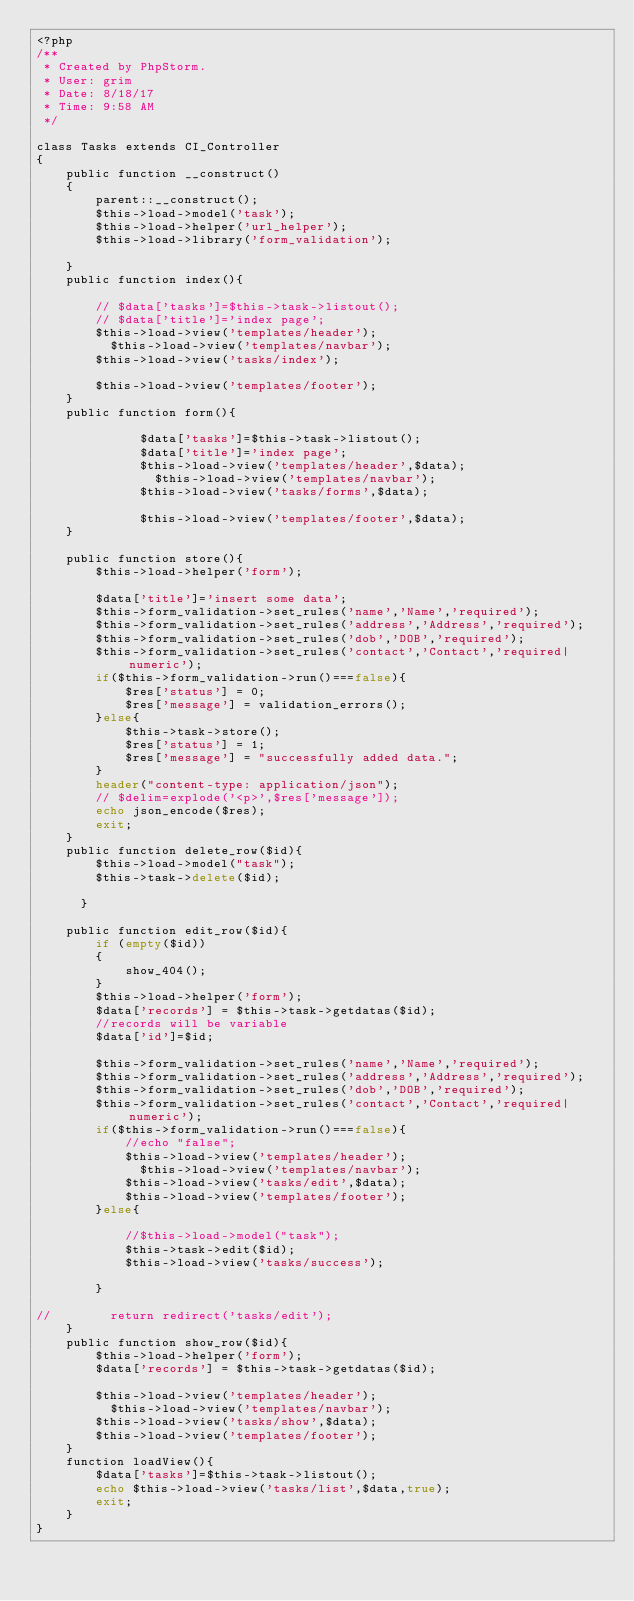<code> <loc_0><loc_0><loc_500><loc_500><_PHP_><?php
/**
 * Created by PhpStorm.
 * User: grim
 * Date: 8/18/17
 * Time: 9:58 AM
 */

class Tasks extends CI_Controller
{
    public function __construct()
    {
        parent::__construct();
        $this->load->model('task');
        $this->load->helper('url_helper');
        $this->load->library('form_validation');

    }
    public function index(){

        // $data['tasks']=$this->task->listout();
        // $data['title']='index page';
        $this->load->view('templates/header');
          $this->load->view('templates/navbar');
        $this->load->view('tasks/index');

        $this->load->view('templates/footer');
    }
    public function form(){

              $data['tasks']=$this->task->listout();
              $data['title']='index page';
              $this->load->view('templates/header',$data);
                $this->load->view('templates/navbar');
              $this->load->view('tasks/forms',$data);

              $this->load->view('templates/footer',$data);
    }

    public function store(){
        $this->load->helper('form');

        $data['title']='insert some data';
        $this->form_validation->set_rules('name','Name','required');
        $this->form_validation->set_rules('address','Address','required');
        $this->form_validation->set_rules('dob','DOB','required');
        $this->form_validation->set_rules('contact','Contact','required|numeric');
        if($this->form_validation->run()===false){
            $res['status'] = 0;
            $res['message'] = validation_errors();
        }else{
            $this->task->store();
            $res['status'] = 1;
            $res['message'] = "successfully added data.";
        }
        header("content-type: application/json");
        // $delim=explode('<p>',$res['message']);
        echo json_encode($res);
        exit;
    }
    public function delete_row($id){
        $this->load->model("task");
        $this->task->delete($id);

      }

    public function edit_row($id){
        if (empty($id))
        {
            show_404();
        }
        $this->load->helper('form');
        $data['records'] = $this->task->getdatas($id);
        //records will be variable
        $data['id']=$id;

        $this->form_validation->set_rules('name','Name','required');
        $this->form_validation->set_rules('address','Address','required');
        $this->form_validation->set_rules('dob','DOB','required');
        $this->form_validation->set_rules('contact','Contact','required|numeric');
        if($this->form_validation->run()===false){
            //echo "false";
            $this->load->view('templates/header');
              $this->load->view('templates/navbar');
            $this->load->view('tasks/edit',$data);
            $this->load->view('templates/footer');
        }else{

            //$this->load->model("task");
            $this->task->edit($id);
            $this->load->view('tasks/success');

        }

//        return redirect('tasks/edit');
    }
    public function show_row($id){
        $this->load->helper('form');
        $data['records'] = $this->task->getdatas($id);

        $this->load->view('templates/header');
          $this->load->view('templates/navbar');
        $this->load->view('tasks/show',$data);
        $this->load->view('templates/footer');
    }
    function loadView(){
        $data['tasks']=$this->task->listout();
        echo $this->load->view('tasks/list',$data,true);
        exit;
    }
}
</code> 